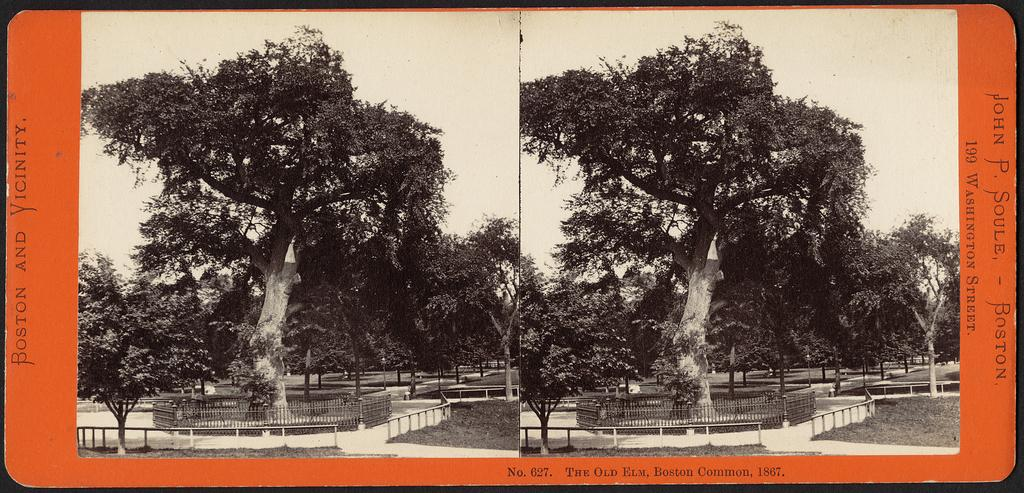What type of picture is in the image? There is a collage picture in the image. What natural elements can be seen in the image? There are trees in the image. What type of barrier surrounds the tree? There is a metal fence around the tree. What type of fang can be seen in the image? There is no fang present in the image. What kind of rat is visible in the image? There is no rat present in the image. 